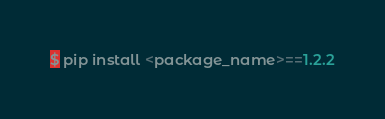Convert code to text. <code><loc_0><loc_0><loc_500><loc_500><_Python_>$ pip install <package_name>==1.2.2

</code> 